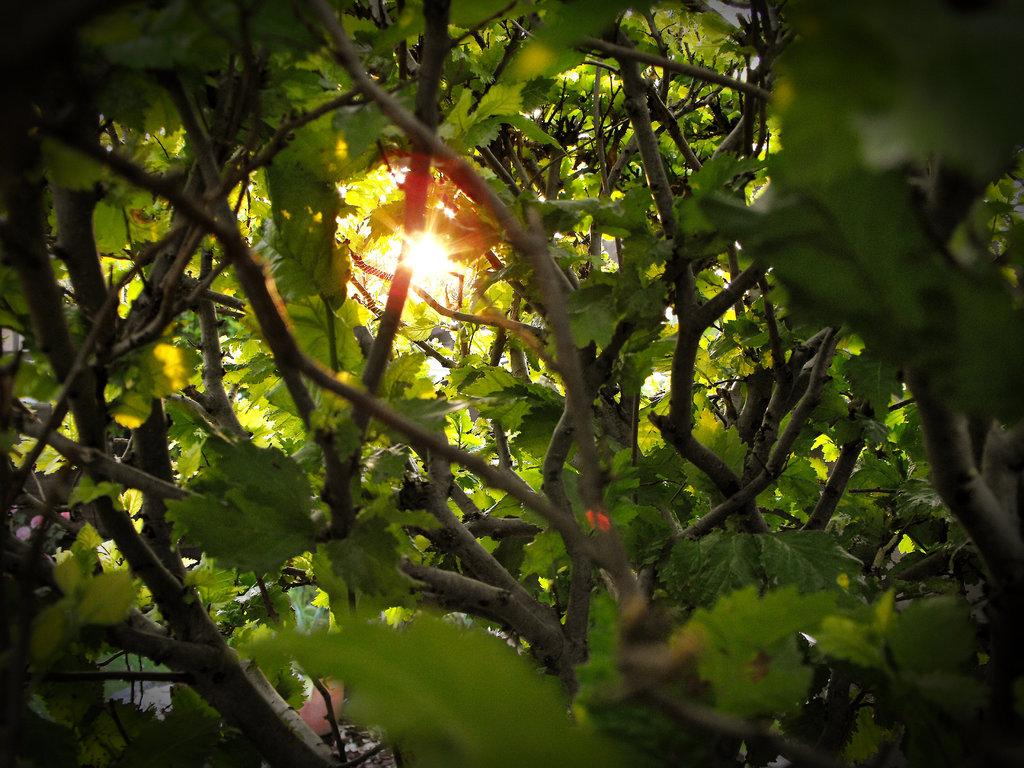What type of vegetation is in the foreground of the image? There are trees in the foreground of the image. What celestial body can be seen in the background of the image? The sun is visible in the background of the image. What type of discovery can be seen in the image? There is no discovery present in the image; it features trees in the foreground and the sun in the background. How many dimes are visible in the image? There are no dimes present in the image. 